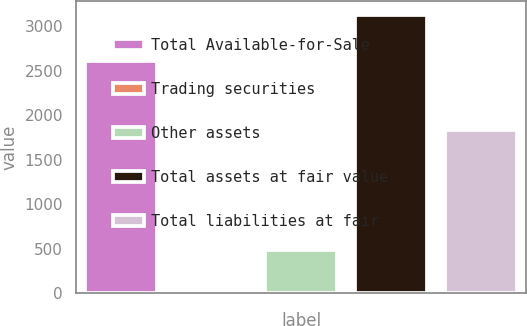Convert chart. <chart><loc_0><loc_0><loc_500><loc_500><bar_chart><fcel>Total Available-for-Sale<fcel>Trading securities<fcel>Other assets<fcel>Total assets at fair value<fcel>Total liabilities at fair<nl><fcel>2613<fcel>30<fcel>487<fcel>3130<fcel>1832<nl></chart> 